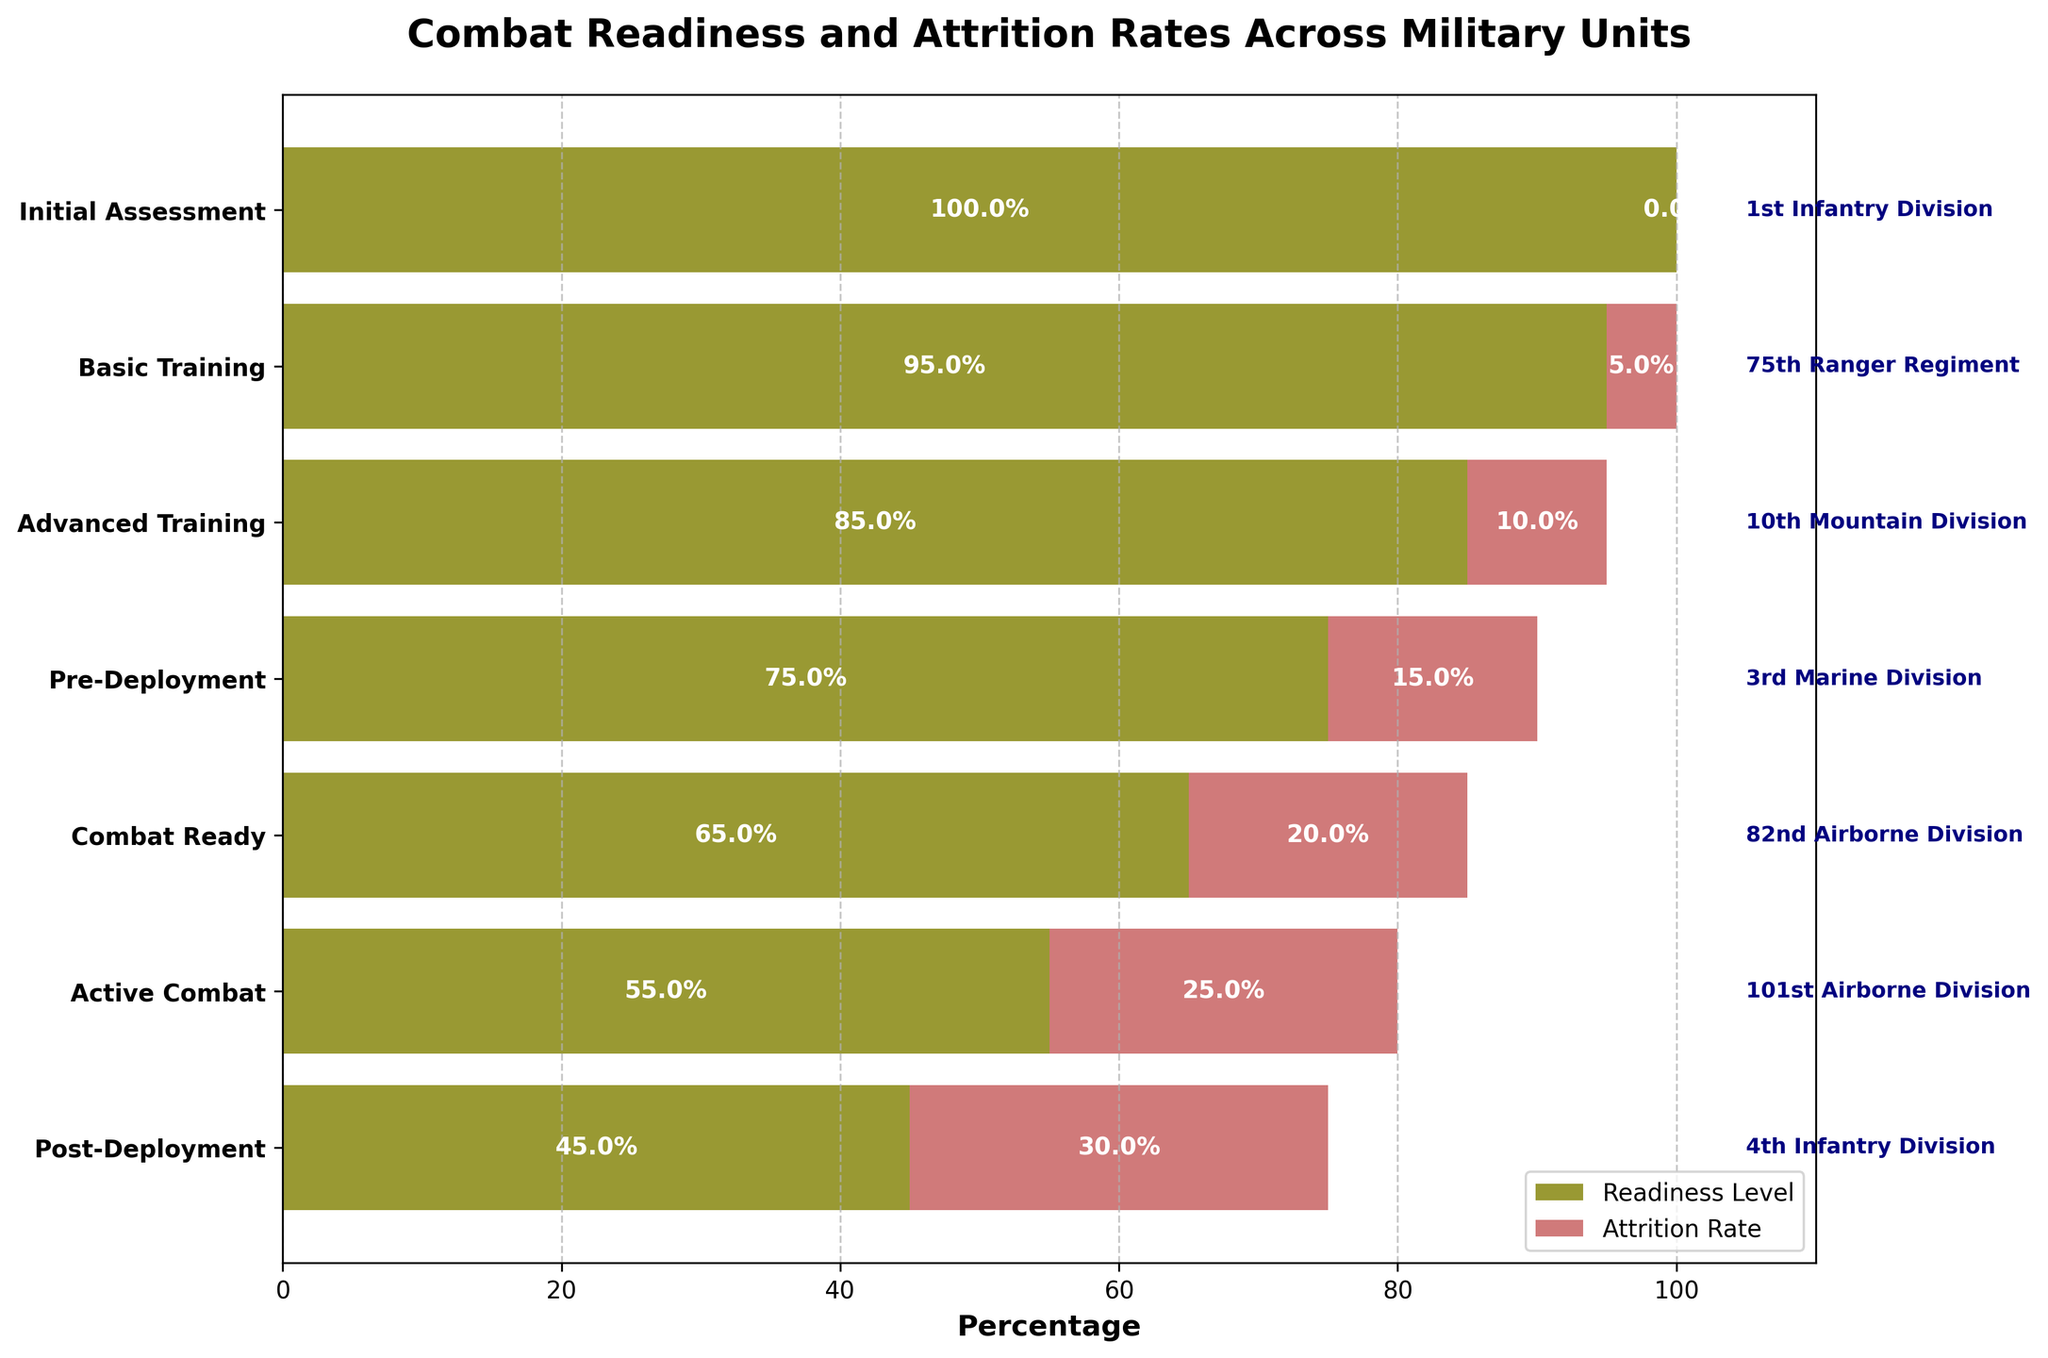How many stages are represented in the figure? Count each unique stage listed on the y-axis of the funnel chart: Initial Assessment, Basic Training, Advanced Training, Pre-Deployment, Combat Ready, Active Combat, Post-Deployment.
Answer: 7 Which stage has the lowest readiness level? Look at the readiness level bars on the left side of the funnel. The shortest one corresponds to Active Combat.
Answer: Active Combat At which stage is the attrition rate the highest? Observe the right side bars representing attrition rates. The longest bar corresponds to Post-Deployment.
Answer: Post-Deployment What is the total readiness level percentage from Initial Assessment to Combat Ready? Add the readiness levels for Initial Assessment: 100%, Basic Training: 95%, Advanced Training: 85%, Pre-Deployment: 75%, Combat Ready: 65%. 100 + 95 + 85 + 75 + 65 = 420.
Answer: 420% How does the attrition rate change from Pre-Deployment to Active Combat? Subtract the attrition rate at Pre-Deployment (15%) from the attrition rate at Active Combat (25%). 25% - 15% = 10%. This indicates an increase of 10%.
Answer: Increased by 10% Which unit has the highest attrition rate in the Combat Ready stage? Identify the unit label at the Combat Ready stage and check the attrition rate bar next to it. The 82nd Airborne Division has a 20% attrition rate at this stage.
Answer: 82nd Airborne Division What is the difference in readiness level between Basic Training and Post-Deployment? Subtract the readiness percentage at Post-Deployment (45%) from the one at Basic Training (95%). 95% - 45% = 50%.
Answer: 50% Which stage shows exactly a 10% attrition rate? Look for the attrition rate bars, the third stage (Advanced Training) has a bar of 10%.
Answer: Advanced Training Compare the readiness levels of the 75th Ranger Regiment and the 101st Airborne Division. The readiness levels for the 75th Ranger Regiment and 101st Airborne Division are 95% and 55% respectively. 95% is greater than 55%.
Answer: 75th Ranger Regiment > 101st Airborne Division Which unit has the second lowest readiness level? Find the second shortest bar on the left side representing readiness level after Active Combat (55%) which is Combat Ready (65%). The unit at this stage is the 82nd Airborne Division.
Answer: 82nd Airborne Division 